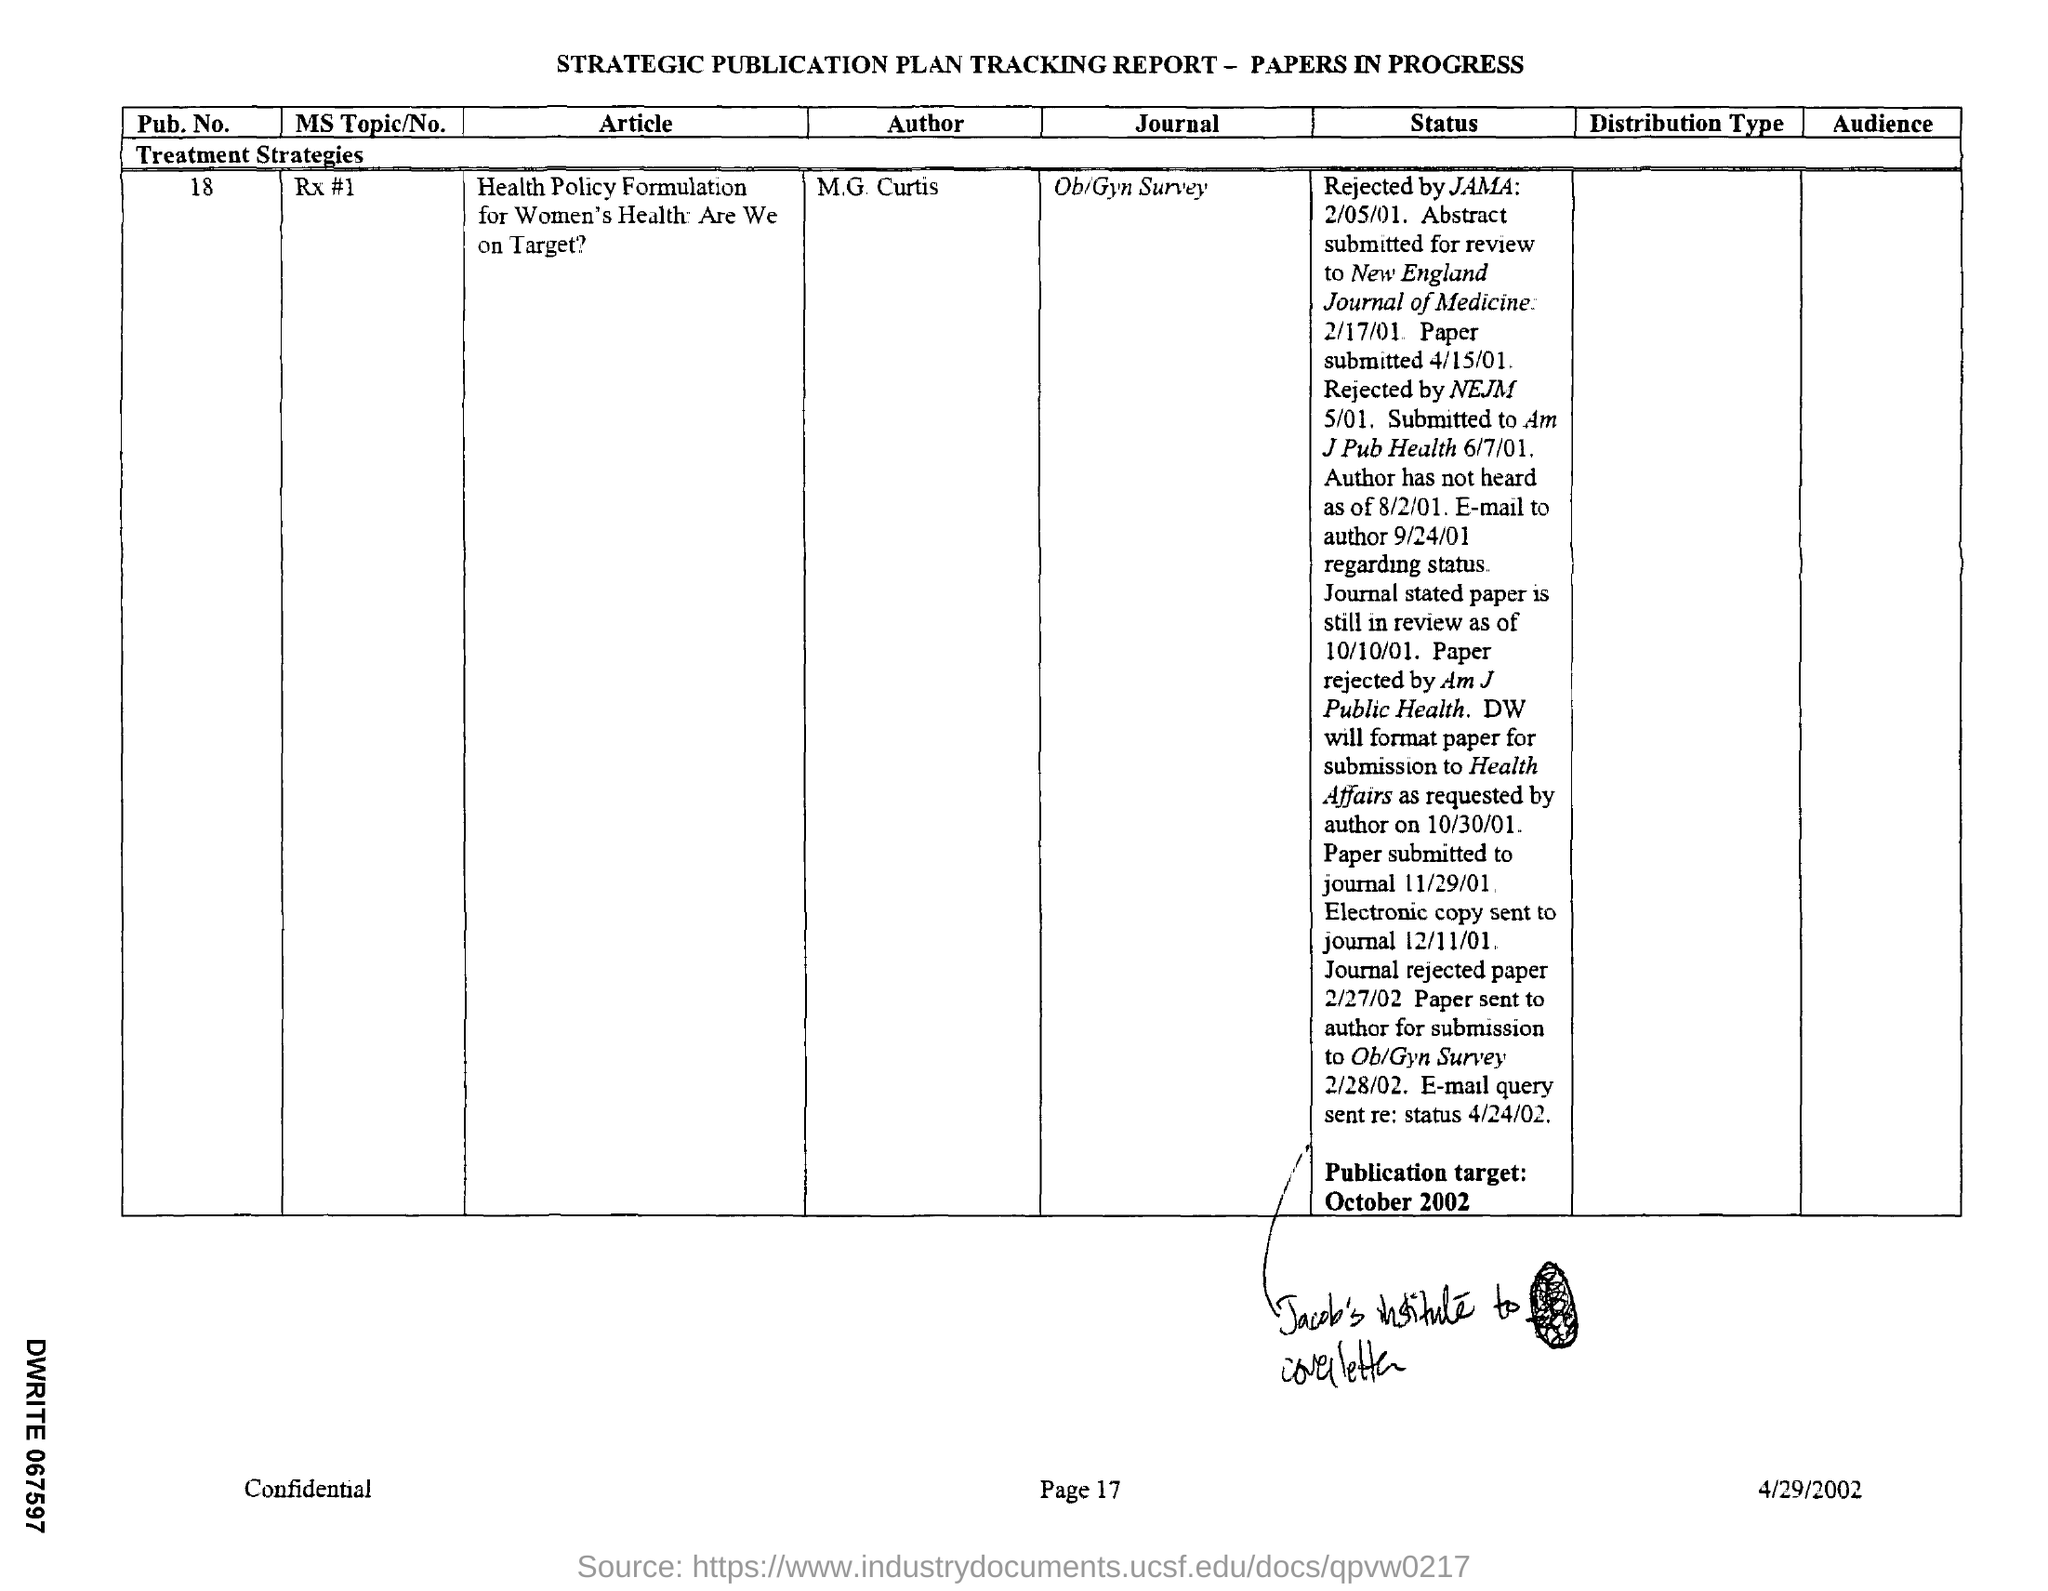What is the name of the author mentioned in the given tracking report ?
Offer a terse response. M.G.Curtis. What is the name of the article mentioned in the given tracking report ?
Give a very brief answer. Health policy formulation for women's health are we on target ?. What is the journal mentioned in the tracking report ?
Offer a terse response. Ob/gyn survey. What is the pub .no. mentioned in the given tracking report ?
Your answer should be compact. 18. When is the publication target given in the report ?
Your response must be concise. OCTOBER 2002. 